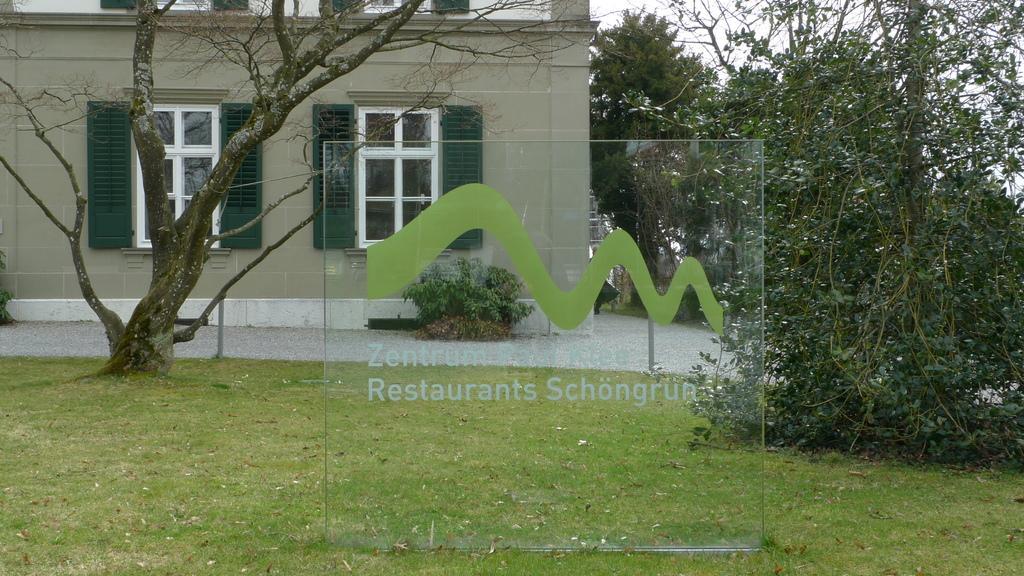Can you describe this image briefly? In this image there is a glass in the middle. In the background there is a building with the windows. On the right side there is a tree. On the ground there is grass. On the left side there is a tree trunk. In the middle there is a glass on which there is some sticker. 